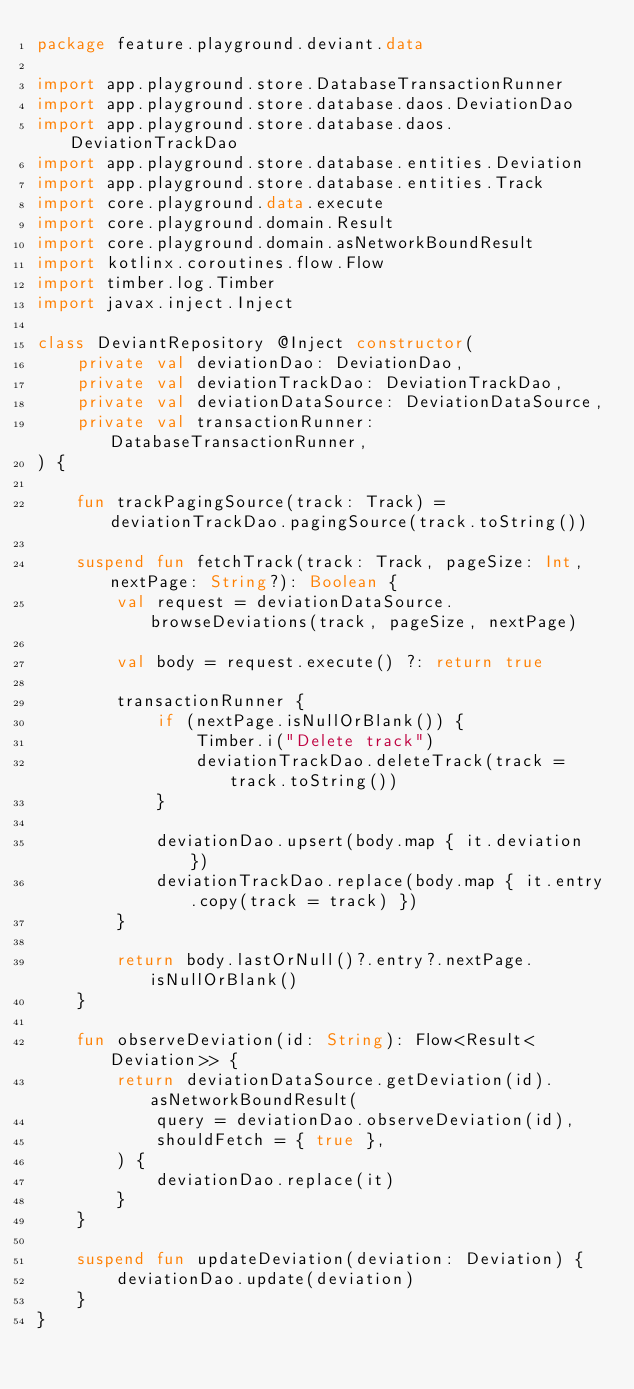Convert code to text. <code><loc_0><loc_0><loc_500><loc_500><_Kotlin_>package feature.playground.deviant.data

import app.playground.store.DatabaseTransactionRunner
import app.playground.store.database.daos.DeviationDao
import app.playground.store.database.daos.DeviationTrackDao
import app.playground.store.database.entities.Deviation
import app.playground.store.database.entities.Track
import core.playground.data.execute
import core.playground.domain.Result
import core.playground.domain.asNetworkBoundResult
import kotlinx.coroutines.flow.Flow
import timber.log.Timber
import javax.inject.Inject

class DeviantRepository @Inject constructor(
    private val deviationDao: DeviationDao,
    private val deviationTrackDao: DeviationTrackDao,
    private val deviationDataSource: DeviationDataSource,
    private val transactionRunner: DatabaseTransactionRunner,
) {

    fun trackPagingSource(track: Track) = deviationTrackDao.pagingSource(track.toString())

    suspend fun fetchTrack(track: Track, pageSize: Int, nextPage: String?): Boolean {
        val request = deviationDataSource.browseDeviations(track, pageSize, nextPage)

        val body = request.execute() ?: return true

        transactionRunner {
            if (nextPage.isNullOrBlank()) {
                Timber.i("Delete track")
                deviationTrackDao.deleteTrack(track = track.toString())
            }

            deviationDao.upsert(body.map { it.deviation })
            deviationTrackDao.replace(body.map { it.entry.copy(track = track) })
        }

        return body.lastOrNull()?.entry?.nextPage.isNullOrBlank()
    }

    fun observeDeviation(id: String): Flow<Result<Deviation>> {
        return deviationDataSource.getDeviation(id).asNetworkBoundResult(
            query = deviationDao.observeDeviation(id),
            shouldFetch = { true },
        ) {
            deviationDao.replace(it)
        }
    }

    suspend fun updateDeviation(deviation: Deviation) {
        deviationDao.update(deviation)
    }
}
</code> 